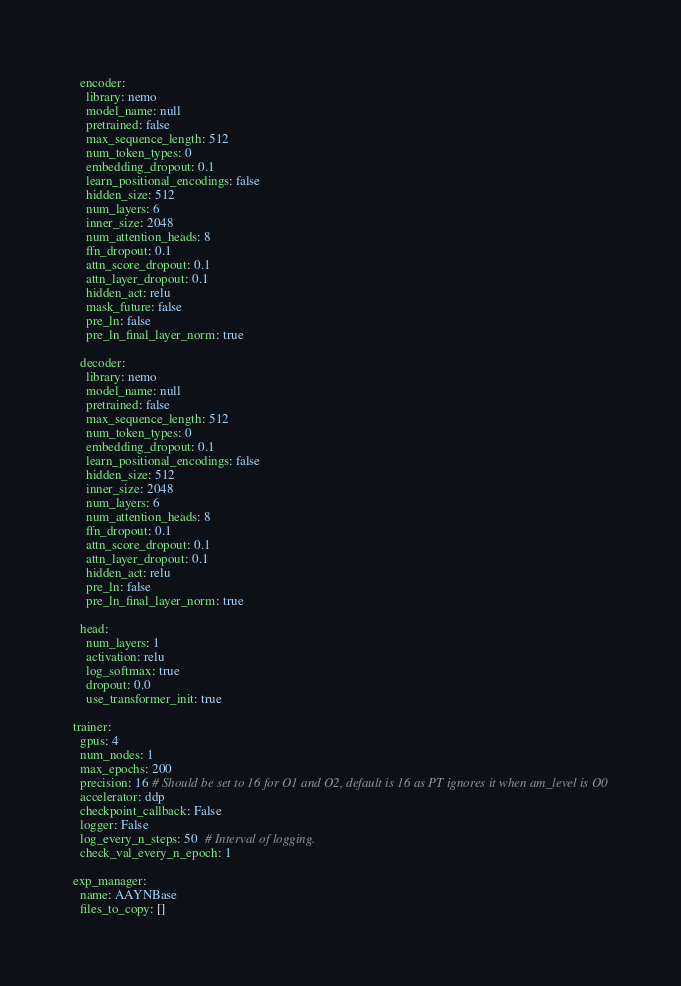<code> <loc_0><loc_0><loc_500><loc_500><_YAML_>  encoder:
    library: nemo
    model_name: null
    pretrained: false
    max_sequence_length: 512
    num_token_types: 0
    embedding_dropout: 0.1
    learn_positional_encodings: false
    hidden_size: 512
    num_layers: 6
    inner_size: 2048
    num_attention_heads: 8
    ffn_dropout: 0.1
    attn_score_dropout: 0.1
    attn_layer_dropout: 0.1
    hidden_act: relu
    mask_future: false
    pre_ln: false
    pre_ln_final_layer_norm: true

  decoder:
    library: nemo
    model_name: null
    pretrained: false
    max_sequence_length: 512
    num_token_types: 0
    embedding_dropout: 0.1
    learn_positional_encodings: false
    hidden_size: 512
    inner_size: 2048
    num_layers: 6
    num_attention_heads: 8
    ffn_dropout: 0.1
    attn_score_dropout: 0.1
    attn_layer_dropout: 0.1
    hidden_act: relu
    pre_ln: false
    pre_ln_final_layer_norm: true

  head:
    num_layers: 1
    activation: relu
    log_softmax: true
    dropout: 0.0
    use_transformer_init: true

trainer:
  gpus: 4
  num_nodes: 1
  max_epochs: 200
  precision: 16 # Should be set to 16 for O1 and O2, default is 16 as PT ignores it when am_level is O0
  accelerator: ddp
  checkpoint_callback: False
  logger: False
  log_every_n_steps: 50  # Interval of logging.
  check_val_every_n_epoch: 1

exp_manager:
  name: AAYNBase
  files_to_copy: []</code> 